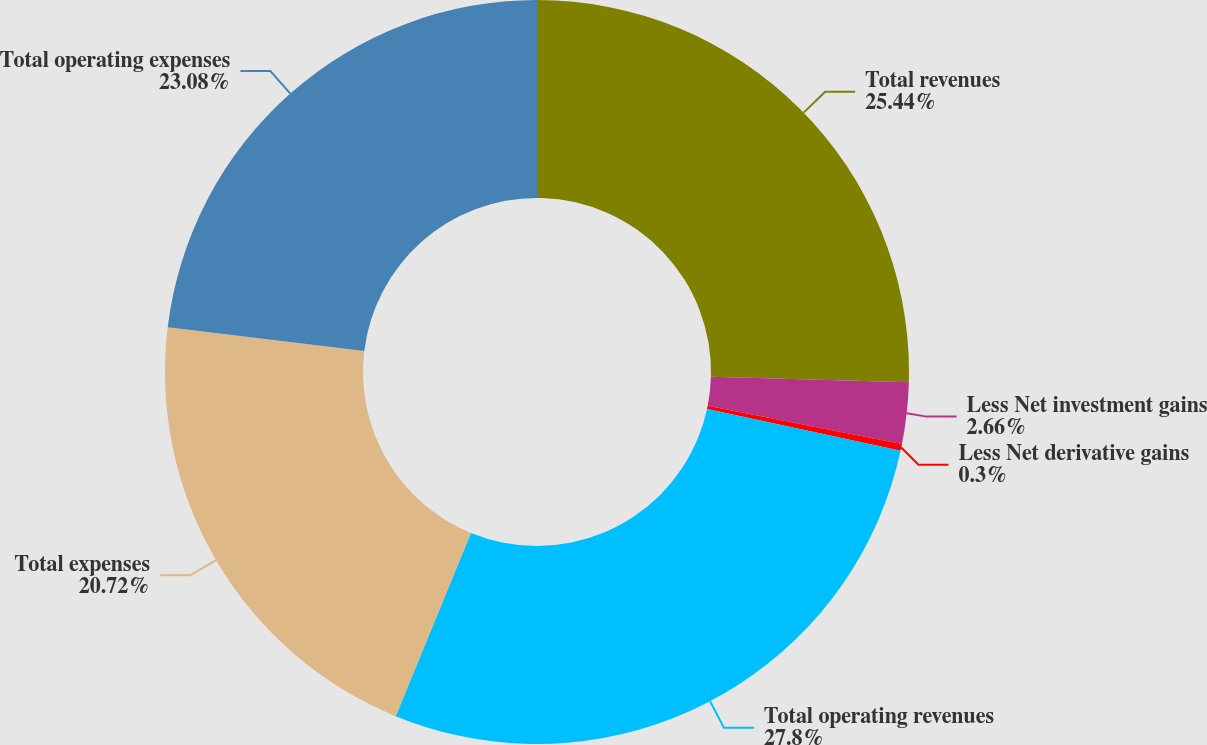<chart> <loc_0><loc_0><loc_500><loc_500><pie_chart><fcel>Total revenues<fcel>Less Net investment gains<fcel>Less Net derivative gains<fcel>Total operating revenues<fcel>Total expenses<fcel>Total operating expenses<nl><fcel>25.44%<fcel>2.66%<fcel>0.3%<fcel>27.8%<fcel>20.72%<fcel>23.08%<nl></chart> 